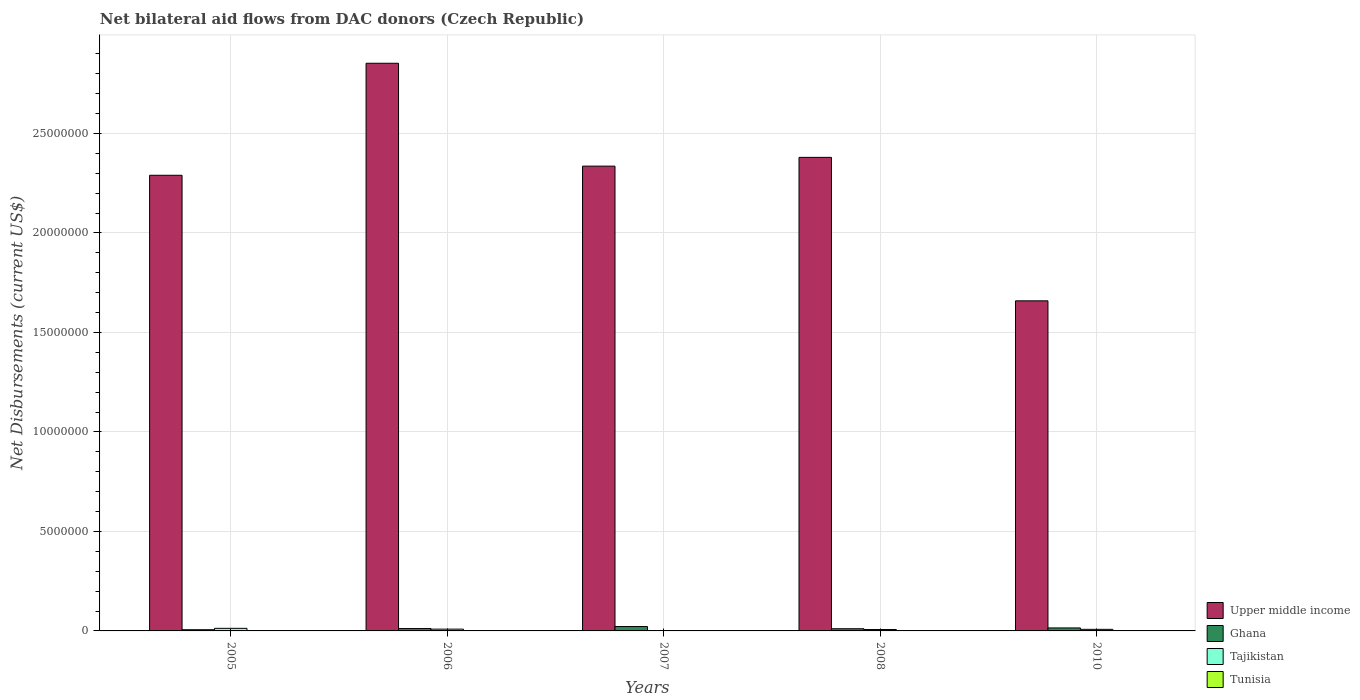How many groups of bars are there?
Offer a terse response. 5. Are the number of bars per tick equal to the number of legend labels?
Offer a terse response. Yes. How many bars are there on the 1st tick from the left?
Your answer should be compact. 4. How many bars are there on the 5th tick from the right?
Provide a short and direct response. 4. In how many cases, is the number of bars for a given year not equal to the number of legend labels?
Offer a terse response. 0. What is the net bilateral aid flows in Tunisia in 2008?
Ensure brevity in your answer.  10000. Across all years, what is the maximum net bilateral aid flows in Upper middle income?
Provide a succinct answer. 2.85e+07. Across all years, what is the minimum net bilateral aid flows in Upper middle income?
Your response must be concise. 1.66e+07. In which year was the net bilateral aid flows in Upper middle income minimum?
Make the answer very short. 2010. What is the difference between the net bilateral aid flows in Upper middle income in 2006 and that in 2010?
Provide a short and direct response. 1.19e+07. What is the difference between the net bilateral aid flows in Tajikistan in 2007 and the net bilateral aid flows in Tunisia in 2005?
Ensure brevity in your answer.  0. What is the average net bilateral aid flows in Tajikistan per year?
Make the answer very short. 7.60e+04. In the year 2010, what is the difference between the net bilateral aid flows in Upper middle income and net bilateral aid flows in Tajikistan?
Give a very brief answer. 1.65e+07. In how many years, is the net bilateral aid flows in Upper middle income greater than 10000000 US$?
Ensure brevity in your answer.  5. Is the net bilateral aid flows in Ghana in 2007 less than that in 2008?
Provide a short and direct response. No. What is the difference between the highest and the second highest net bilateral aid flows in Tunisia?
Offer a very short reply. 0. What is the difference between the highest and the lowest net bilateral aid flows in Ghana?
Keep it short and to the point. 1.60e+05. In how many years, is the net bilateral aid flows in Ghana greater than the average net bilateral aid flows in Ghana taken over all years?
Offer a terse response. 2. What does the 4th bar from the left in 2007 represents?
Your answer should be very brief. Tunisia. What does the 4th bar from the right in 2007 represents?
Your response must be concise. Upper middle income. How many bars are there?
Keep it short and to the point. 20. Are all the bars in the graph horizontal?
Keep it short and to the point. No. How many years are there in the graph?
Give a very brief answer. 5. What is the difference between two consecutive major ticks on the Y-axis?
Your answer should be very brief. 5.00e+06. Are the values on the major ticks of Y-axis written in scientific E-notation?
Give a very brief answer. No. Where does the legend appear in the graph?
Your response must be concise. Bottom right. How many legend labels are there?
Offer a very short reply. 4. How are the legend labels stacked?
Provide a short and direct response. Vertical. What is the title of the graph?
Provide a short and direct response. Net bilateral aid flows from DAC donors (Czech Republic). Does "Benin" appear as one of the legend labels in the graph?
Ensure brevity in your answer.  No. What is the label or title of the X-axis?
Ensure brevity in your answer.  Years. What is the label or title of the Y-axis?
Give a very brief answer. Net Disbursements (current US$). What is the Net Disbursements (current US$) in Upper middle income in 2005?
Make the answer very short. 2.29e+07. What is the Net Disbursements (current US$) of Ghana in 2005?
Offer a terse response. 6.00e+04. What is the Net Disbursements (current US$) of Tajikistan in 2005?
Provide a succinct answer. 1.30e+05. What is the Net Disbursements (current US$) of Tunisia in 2005?
Make the answer very short. 10000. What is the Net Disbursements (current US$) in Upper middle income in 2006?
Offer a very short reply. 2.85e+07. What is the Net Disbursements (current US$) of Ghana in 2006?
Provide a short and direct response. 1.20e+05. What is the Net Disbursements (current US$) in Upper middle income in 2007?
Keep it short and to the point. 2.34e+07. What is the Net Disbursements (current US$) in Tunisia in 2007?
Keep it short and to the point. 10000. What is the Net Disbursements (current US$) of Upper middle income in 2008?
Ensure brevity in your answer.  2.38e+07. What is the Net Disbursements (current US$) of Tunisia in 2008?
Your answer should be very brief. 10000. What is the Net Disbursements (current US$) of Upper middle income in 2010?
Make the answer very short. 1.66e+07. What is the Net Disbursements (current US$) in Ghana in 2010?
Your response must be concise. 1.50e+05. Across all years, what is the maximum Net Disbursements (current US$) in Upper middle income?
Give a very brief answer. 2.85e+07. Across all years, what is the maximum Net Disbursements (current US$) in Ghana?
Keep it short and to the point. 2.20e+05. Across all years, what is the maximum Net Disbursements (current US$) of Tajikistan?
Keep it short and to the point. 1.30e+05. Across all years, what is the maximum Net Disbursements (current US$) of Tunisia?
Offer a terse response. 2.00e+04. Across all years, what is the minimum Net Disbursements (current US$) of Upper middle income?
Your answer should be very brief. 1.66e+07. Across all years, what is the minimum Net Disbursements (current US$) of Ghana?
Offer a very short reply. 6.00e+04. Across all years, what is the minimum Net Disbursements (current US$) in Tunisia?
Make the answer very short. 10000. What is the total Net Disbursements (current US$) in Upper middle income in the graph?
Offer a terse response. 1.15e+08. What is the total Net Disbursements (current US$) of Ghana in the graph?
Make the answer very short. 6.60e+05. What is the total Net Disbursements (current US$) of Tajikistan in the graph?
Keep it short and to the point. 3.80e+05. What is the total Net Disbursements (current US$) in Tunisia in the graph?
Make the answer very short. 7.00e+04. What is the difference between the Net Disbursements (current US$) of Upper middle income in 2005 and that in 2006?
Make the answer very short. -5.63e+06. What is the difference between the Net Disbursements (current US$) in Ghana in 2005 and that in 2006?
Make the answer very short. -6.00e+04. What is the difference between the Net Disbursements (current US$) in Tajikistan in 2005 and that in 2006?
Your answer should be compact. 4.00e+04. What is the difference between the Net Disbursements (current US$) in Upper middle income in 2005 and that in 2007?
Your answer should be very brief. -4.60e+05. What is the difference between the Net Disbursements (current US$) of Tunisia in 2005 and that in 2007?
Offer a very short reply. 0. What is the difference between the Net Disbursements (current US$) in Upper middle income in 2005 and that in 2008?
Your answer should be very brief. -9.00e+05. What is the difference between the Net Disbursements (current US$) of Upper middle income in 2005 and that in 2010?
Ensure brevity in your answer.  6.31e+06. What is the difference between the Net Disbursements (current US$) in Ghana in 2005 and that in 2010?
Your answer should be compact. -9.00e+04. What is the difference between the Net Disbursements (current US$) in Upper middle income in 2006 and that in 2007?
Keep it short and to the point. 5.17e+06. What is the difference between the Net Disbursements (current US$) in Tunisia in 2006 and that in 2007?
Your answer should be compact. 10000. What is the difference between the Net Disbursements (current US$) of Upper middle income in 2006 and that in 2008?
Offer a very short reply. 4.73e+06. What is the difference between the Net Disbursements (current US$) of Ghana in 2006 and that in 2008?
Offer a very short reply. 10000. What is the difference between the Net Disbursements (current US$) of Tunisia in 2006 and that in 2008?
Your answer should be very brief. 10000. What is the difference between the Net Disbursements (current US$) of Upper middle income in 2006 and that in 2010?
Keep it short and to the point. 1.19e+07. What is the difference between the Net Disbursements (current US$) of Tunisia in 2006 and that in 2010?
Keep it short and to the point. 0. What is the difference between the Net Disbursements (current US$) in Upper middle income in 2007 and that in 2008?
Your answer should be very brief. -4.40e+05. What is the difference between the Net Disbursements (current US$) of Tunisia in 2007 and that in 2008?
Ensure brevity in your answer.  0. What is the difference between the Net Disbursements (current US$) of Upper middle income in 2007 and that in 2010?
Offer a very short reply. 6.77e+06. What is the difference between the Net Disbursements (current US$) in Tajikistan in 2007 and that in 2010?
Ensure brevity in your answer.  -7.00e+04. What is the difference between the Net Disbursements (current US$) in Upper middle income in 2008 and that in 2010?
Offer a very short reply. 7.21e+06. What is the difference between the Net Disbursements (current US$) of Ghana in 2008 and that in 2010?
Make the answer very short. -4.00e+04. What is the difference between the Net Disbursements (current US$) in Upper middle income in 2005 and the Net Disbursements (current US$) in Ghana in 2006?
Ensure brevity in your answer.  2.28e+07. What is the difference between the Net Disbursements (current US$) of Upper middle income in 2005 and the Net Disbursements (current US$) of Tajikistan in 2006?
Provide a short and direct response. 2.28e+07. What is the difference between the Net Disbursements (current US$) in Upper middle income in 2005 and the Net Disbursements (current US$) in Tunisia in 2006?
Offer a terse response. 2.29e+07. What is the difference between the Net Disbursements (current US$) in Ghana in 2005 and the Net Disbursements (current US$) in Tunisia in 2006?
Offer a very short reply. 4.00e+04. What is the difference between the Net Disbursements (current US$) in Upper middle income in 2005 and the Net Disbursements (current US$) in Ghana in 2007?
Make the answer very short. 2.27e+07. What is the difference between the Net Disbursements (current US$) in Upper middle income in 2005 and the Net Disbursements (current US$) in Tajikistan in 2007?
Your response must be concise. 2.29e+07. What is the difference between the Net Disbursements (current US$) in Upper middle income in 2005 and the Net Disbursements (current US$) in Tunisia in 2007?
Give a very brief answer. 2.29e+07. What is the difference between the Net Disbursements (current US$) of Ghana in 2005 and the Net Disbursements (current US$) of Tajikistan in 2007?
Your answer should be very brief. 5.00e+04. What is the difference between the Net Disbursements (current US$) in Tajikistan in 2005 and the Net Disbursements (current US$) in Tunisia in 2007?
Offer a terse response. 1.20e+05. What is the difference between the Net Disbursements (current US$) in Upper middle income in 2005 and the Net Disbursements (current US$) in Ghana in 2008?
Keep it short and to the point. 2.28e+07. What is the difference between the Net Disbursements (current US$) of Upper middle income in 2005 and the Net Disbursements (current US$) of Tajikistan in 2008?
Provide a succinct answer. 2.28e+07. What is the difference between the Net Disbursements (current US$) of Upper middle income in 2005 and the Net Disbursements (current US$) of Tunisia in 2008?
Your response must be concise. 2.29e+07. What is the difference between the Net Disbursements (current US$) in Tajikistan in 2005 and the Net Disbursements (current US$) in Tunisia in 2008?
Ensure brevity in your answer.  1.20e+05. What is the difference between the Net Disbursements (current US$) of Upper middle income in 2005 and the Net Disbursements (current US$) of Ghana in 2010?
Your answer should be compact. 2.28e+07. What is the difference between the Net Disbursements (current US$) of Upper middle income in 2005 and the Net Disbursements (current US$) of Tajikistan in 2010?
Offer a terse response. 2.28e+07. What is the difference between the Net Disbursements (current US$) in Upper middle income in 2005 and the Net Disbursements (current US$) in Tunisia in 2010?
Provide a short and direct response. 2.29e+07. What is the difference between the Net Disbursements (current US$) in Upper middle income in 2006 and the Net Disbursements (current US$) in Ghana in 2007?
Your answer should be very brief. 2.83e+07. What is the difference between the Net Disbursements (current US$) in Upper middle income in 2006 and the Net Disbursements (current US$) in Tajikistan in 2007?
Provide a short and direct response. 2.85e+07. What is the difference between the Net Disbursements (current US$) of Upper middle income in 2006 and the Net Disbursements (current US$) of Tunisia in 2007?
Offer a very short reply. 2.85e+07. What is the difference between the Net Disbursements (current US$) of Tajikistan in 2006 and the Net Disbursements (current US$) of Tunisia in 2007?
Your response must be concise. 8.00e+04. What is the difference between the Net Disbursements (current US$) in Upper middle income in 2006 and the Net Disbursements (current US$) in Ghana in 2008?
Your answer should be very brief. 2.84e+07. What is the difference between the Net Disbursements (current US$) of Upper middle income in 2006 and the Net Disbursements (current US$) of Tajikistan in 2008?
Provide a short and direct response. 2.85e+07. What is the difference between the Net Disbursements (current US$) in Upper middle income in 2006 and the Net Disbursements (current US$) in Tunisia in 2008?
Ensure brevity in your answer.  2.85e+07. What is the difference between the Net Disbursements (current US$) in Ghana in 2006 and the Net Disbursements (current US$) in Tunisia in 2008?
Your answer should be compact. 1.10e+05. What is the difference between the Net Disbursements (current US$) in Upper middle income in 2006 and the Net Disbursements (current US$) in Ghana in 2010?
Your answer should be very brief. 2.84e+07. What is the difference between the Net Disbursements (current US$) of Upper middle income in 2006 and the Net Disbursements (current US$) of Tajikistan in 2010?
Provide a short and direct response. 2.84e+07. What is the difference between the Net Disbursements (current US$) of Upper middle income in 2006 and the Net Disbursements (current US$) of Tunisia in 2010?
Make the answer very short. 2.85e+07. What is the difference between the Net Disbursements (current US$) in Ghana in 2006 and the Net Disbursements (current US$) in Tunisia in 2010?
Your answer should be very brief. 1.00e+05. What is the difference between the Net Disbursements (current US$) in Upper middle income in 2007 and the Net Disbursements (current US$) in Ghana in 2008?
Provide a succinct answer. 2.32e+07. What is the difference between the Net Disbursements (current US$) of Upper middle income in 2007 and the Net Disbursements (current US$) of Tajikistan in 2008?
Offer a terse response. 2.33e+07. What is the difference between the Net Disbursements (current US$) of Upper middle income in 2007 and the Net Disbursements (current US$) of Tunisia in 2008?
Your answer should be compact. 2.34e+07. What is the difference between the Net Disbursements (current US$) in Tajikistan in 2007 and the Net Disbursements (current US$) in Tunisia in 2008?
Give a very brief answer. 0. What is the difference between the Net Disbursements (current US$) of Upper middle income in 2007 and the Net Disbursements (current US$) of Ghana in 2010?
Offer a terse response. 2.32e+07. What is the difference between the Net Disbursements (current US$) of Upper middle income in 2007 and the Net Disbursements (current US$) of Tajikistan in 2010?
Make the answer very short. 2.33e+07. What is the difference between the Net Disbursements (current US$) in Upper middle income in 2007 and the Net Disbursements (current US$) in Tunisia in 2010?
Offer a terse response. 2.33e+07. What is the difference between the Net Disbursements (current US$) in Ghana in 2007 and the Net Disbursements (current US$) in Tajikistan in 2010?
Your response must be concise. 1.40e+05. What is the difference between the Net Disbursements (current US$) of Ghana in 2007 and the Net Disbursements (current US$) of Tunisia in 2010?
Ensure brevity in your answer.  2.00e+05. What is the difference between the Net Disbursements (current US$) of Upper middle income in 2008 and the Net Disbursements (current US$) of Ghana in 2010?
Your answer should be very brief. 2.36e+07. What is the difference between the Net Disbursements (current US$) in Upper middle income in 2008 and the Net Disbursements (current US$) in Tajikistan in 2010?
Ensure brevity in your answer.  2.37e+07. What is the difference between the Net Disbursements (current US$) of Upper middle income in 2008 and the Net Disbursements (current US$) of Tunisia in 2010?
Provide a succinct answer. 2.38e+07. What is the difference between the Net Disbursements (current US$) of Ghana in 2008 and the Net Disbursements (current US$) of Tunisia in 2010?
Provide a short and direct response. 9.00e+04. What is the difference between the Net Disbursements (current US$) in Tajikistan in 2008 and the Net Disbursements (current US$) in Tunisia in 2010?
Ensure brevity in your answer.  5.00e+04. What is the average Net Disbursements (current US$) of Upper middle income per year?
Make the answer very short. 2.30e+07. What is the average Net Disbursements (current US$) in Ghana per year?
Your response must be concise. 1.32e+05. What is the average Net Disbursements (current US$) of Tajikistan per year?
Your answer should be compact. 7.60e+04. What is the average Net Disbursements (current US$) in Tunisia per year?
Provide a succinct answer. 1.40e+04. In the year 2005, what is the difference between the Net Disbursements (current US$) of Upper middle income and Net Disbursements (current US$) of Ghana?
Provide a succinct answer. 2.28e+07. In the year 2005, what is the difference between the Net Disbursements (current US$) in Upper middle income and Net Disbursements (current US$) in Tajikistan?
Your response must be concise. 2.28e+07. In the year 2005, what is the difference between the Net Disbursements (current US$) of Upper middle income and Net Disbursements (current US$) of Tunisia?
Your answer should be compact. 2.29e+07. In the year 2005, what is the difference between the Net Disbursements (current US$) in Ghana and Net Disbursements (current US$) in Tunisia?
Provide a short and direct response. 5.00e+04. In the year 2005, what is the difference between the Net Disbursements (current US$) in Tajikistan and Net Disbursements (current US$) in Tunisia?
Your response must be concise. 1.20e+05. In the year 2006, what is the difference between the Net Disbursements (current US$) in Upper middle income and Net Disbursements (current US$) in Ghana?
Your answer should be very brief. 2.84e+07. In the year 2006, what is the difference between the Net Disbursements (current US$) in Upper middle income and Net Disbursements (current US$) in Tajikistan?
Your response must be concise. 2.84e+07. In the year 2006, what is the difference between the Net Disbursements (current US$) of Upper middle income and Net Disbursements (current US$) of Tunisia?
Your response must be concise. 2.85e+07. In the year 2006, what is the difference between the Net Disbursements (current US$) of Ghana and Net Disbursements (current US$) of Tajikistan?
Provide a succinct answer. 3.00e+04. In the year 2006, what is the difference between the Net Disbursements (current US$) in Tajikistan and Net Disbursements (current US$) in Tunisia?
Offer a terse response. 7.00e+04. In the year 2007, what is the difference between the Net Disbursements (current US$) of Upper middle income and Net Disbursements (current US$) of Ghana?
Provide a short and direct response. 2.31e+07. In the year 2007, what is the difference between the Net Disbursements (current US$) of Upper middle income and Net Disbursements (current US$) of Tajikistan?
Offer a very short reply. 2.34e+07. In the year 2007, what is the difference between the Net Disbursements (current US$) in Upper middle income and Net Disbursements (current US$) in Tunisia?
Provide a succinct answer. 2.34e+07. In the year 2007, what is the difference between the Net Disbursements (current US$) in Ghana and Net Disbursements (current US$) in Tajikistan?
Provide a succinct answer. 2.10e+05. In the year 2007, what is the difference between the Net Disbursements (current US$) in Ghana and Net Disbursements (current US$) in Tunisia?
Ensure brevity in your answer.  2.10e+05. In the year 2008, what is the difference between the Net Disbursements (current US$) in Upper middle income and Net Disbursements (current US$) in Ghana?
Ensure brevity in your answer.  2.37e+07. In the year 2008, what is the difference between the Net Disbursements (current US$) in Upper middle income and Net Disbursements (current US$) in Tajikistan?
Your answer should be very brief. 2.37e+07. In the year 2008, what is the difference between the Net Disbursements (current US$) in Upper middle income and Net Disbursements (current US$) in Tunisia?
Your response must be concise. 2.38e+07. In the year 2010, what is the difference between the Net Disbursements (current US$) of Upper middle income and Net Disbursements (current US$) of Ghana?
Provide a succinct answer. 1.64e+07. In the year 2010, what is the difference between the Net Disbursements (current US$) of Upper middle income and Net Disbursements (current US$) of Tajikistan?
Give a very brief answer. 1.65e+07. In the year 2010, what is the difference between the Net Disbursements (current US$) in Upper middle income and Net Disbursements (current US$) in Tunisia?
Your answer should be very brief. 1.66e+07. What is the ratio of the Net Disbursements (current US$) in Upper middle income in 2005 to that in 2006?
Offer a very short reply. 0.8. What is the ratio of the Net Disbursements (current US$) in Ghana in 2005 to that in 2006?
Offer a terse response. 0.5. What is the ratio of the Net Disbursements (current US$) in Tajikistan in 2005 to that in 2006?
Provide a succinct answer. 1.44. What is the ratio of the Net Disbursements (current US$) in Upper middle income in 2005 to that in 2007?
Ensure brevity in your answer.  0.98. What is the ratio of the Net Disbursements (current US$) in Ghana in 2005 to that in 2007?
Your answer should be compact. 0.27. What is the ratio of the Net Disbursements (current US$) in Tajikistan in 2005 to that in 2007?
Your response must be concise. 13. What is the ratio of the Net Disbursements (current US$) in Upper middle income in 2005 to that in 2008?
Your answer should be compact. 0.96. What is the ratio of the Net Disbursements (current US$) of Ghana in 2005 to that in 2008?
Offer a terse response. 0.55. What is the ratio of the Net Disbursements (current US$) in Tajikistan in 2005 to that in 2008?
Your response must be concise. 1.86. What is the ratio of the Net Disbursements (current US$) in Tunisia in 2005 to that in 2008?
Give a very brief answer. 1. What is the ratio of the Net Disbursements (current US$) of Upper middle income in 2005 to that in 2010?
Your answer should be very brief. 1.38. What is the ratio of the Net Disbursements (current US$) of Ghana in 2005 to that in 2010?
Your answer should be very brief. 0.4. What is the ratio of the Net Disbursements (current US$) in Tajikistan in 2005 to that in 2010?
Provide a short and direct response. 1.62. What is the ratio of the Net Disbursements (current US$) in Upper middle income in 2006 to that in 2007?
Your answer should be compact. 1.22. What is the ratio of the Net Disbursements (current US$) of Ghana in 2006 to that in 2007?
Offer a terse response. 0.55. What is the ratio of the Net Disbursements (current US$) of Tunisia in 2006 to that in 2007?
Your answer should be compact. 2. What is the ratio of the Net Disbursements (current US$) in Upper middle income in 2006 to that in 2008?
Offer a very short reply. 1.2. What is the ratio of the Net Disbursements (current US$) of Ghana in 2006 to that in 2008?
Your answer should be compact. 1.09. What is the ratio of the Net Disbursements (current US$) of Upper middle income in 2006 to that in 2010?
Provide a short and direct response. 1.72. What is the ratio of the Net Disbursements (current US$) in Ghana in 2006 to that in 2010?
Provide a short and direct response. 0.8. What is the ratio of the Net Disbursements (current US$) in Upper middle income in 2007 to that in 2008?
Your response must be concise. 0.98. What is the ratio of the Net Disbursements (current US$) in Ghana in 2007 to that in 2008?
Make the answer very short. 2. What is the ratio of the Net Disbursements (current US$) in Tajikistan in 2007 to that in 2008?
Provide a short and direct response. 0.14. What is the ratio of the Net Disbursements (current US$) in Tunisia in 2007 to that in 2008?
Make the answer very short. 1. What is the ratio of the Net Disbursements (current US$) in Upper middle income in 2007 to that in 2010?
Make the answer very short. 1.41. What is the ratio of the Net Disbursements (current US$) in Ghana in 2007 to that in 2010?
Provide a succinct answer. 1.47. What is the ratio of the Net Disbursements (current US$) in Tajikistan in 2007 to that in 2010?
Your answer should be compact. 0.12. What is the ratio of the Net Disbursements (current US$) of Upper middle income in 2008 to that in 2010?
Offer a terse response. 1.43. What is the ratio of the Net Disbursements (current US$) of Ghana in 2008 to that in 2010?
Offer a terse response. 0.73. What is the ratio of the Net Disbursements (current US$) in Tajikistan in 2008 to that in 2010?
Your response must be concise. 0.88. What is the difference between the highest and the second highest Net Disbursements (current US$) of Upper middle income?
Ensure brevity in your answer.  4.73e+06. What is the difference between the highest and the second highest Net Disbursements (current US$) in Ghana?
Keep it short and to the point. 7.00e+04. What is the difference between the highest and the second highest Net Disbursements (current US$) in Tajikistan?
Your answer should be very brief. 4.00e+04. What is the difference between the highest and the second highest Net Disbursements (current US$) in Tunisia?
Give a very brief answer. 0. What is the difference between the highest and the lowest Net Disbursements (current US$) of Upper middle income?
Make the answer very short. 1.19e+07. 